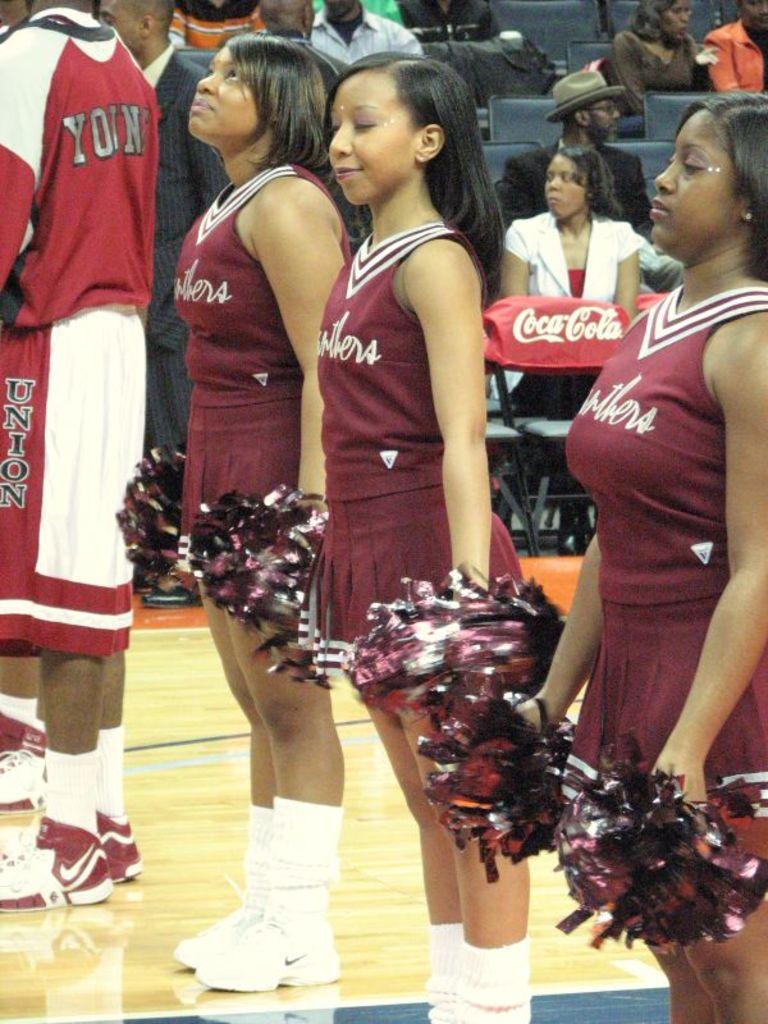What is the name of the soda on the chair on the floor?
Offer a terse response. Coca-cola. What team are those girls cheering for?
Your answer should be compact. Unanswerable. 